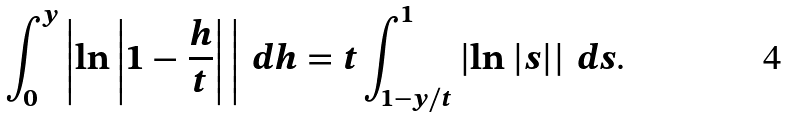<formula> <loc_0><loc_0><loc_500><loc_500>\int _ { 0 } ^ { y } \left | \ln \left | 1 - \frac { h } { t } \right | \, \right | \, d h = t \int _ { 1 - y / t } ^ { 1 } \left | \ln | s | \right | \, d s .</formula> 